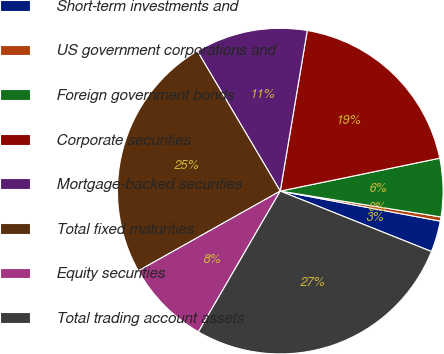Convert chart. <chart><loc_0><loc_0><loc_500><loc_500><pie_chart><fcel>Short-term investments and<fcel>US government corporations and<fcel>Foreign government bonds<fcel>Corporate securities<fcel>Mortgage-backed securities<fcel>Total fixed maturities<fcel>Equity securities<fcel>Total trading account assets<nl><fcel>3.1%<fcel>0.41%<fcel>5.78%<fcel>19.11%<fcel>11.16%<fcel>24.64%<fcel>8.47%<fcel>27.33%<nl></chart> 